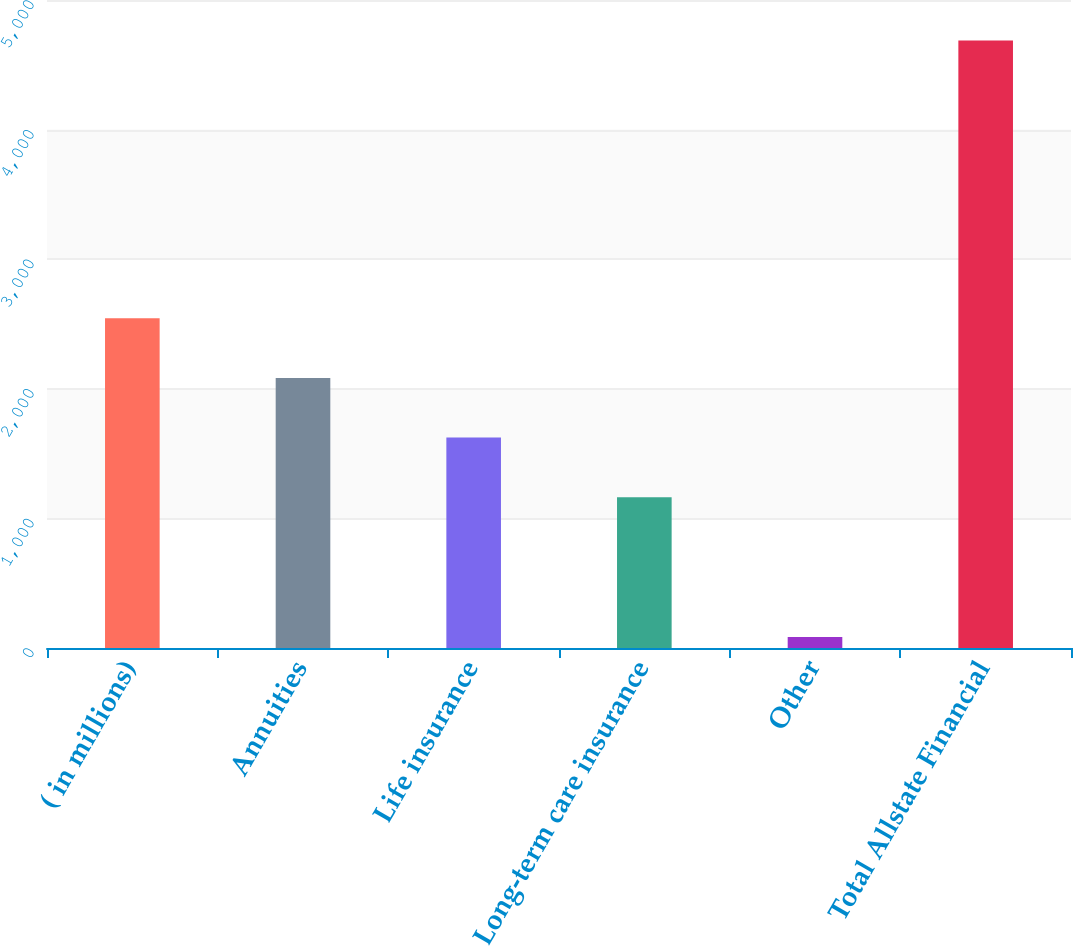Convert chart. <chart><loc_0><loc_0><loc_500><loc_500><bar_chart><fcel>( in millions)<fcel>Annuities<fcel>Life insurance<fcel>Long-term care insurance<fcel>Other<fcel>Total Allstate Financial<nl><fcel>2543.9<fcel>2083.6<fcel>1623.3<fcel>1163<fcel>85<fcel>4688<nl></chart> 